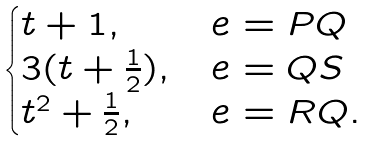Convert formula to latex. <formula><loc_0><loc_0><loc_500><loc_500>\begin{cases} t + 1 , & e = P Q \\ 3 ( t + \frac { 1 } { 2 } ) , & e = Q S \\ t ^ { 2 } + \frac { 1 } { 2 } , & e = R Q . \end{cases}</formula> 